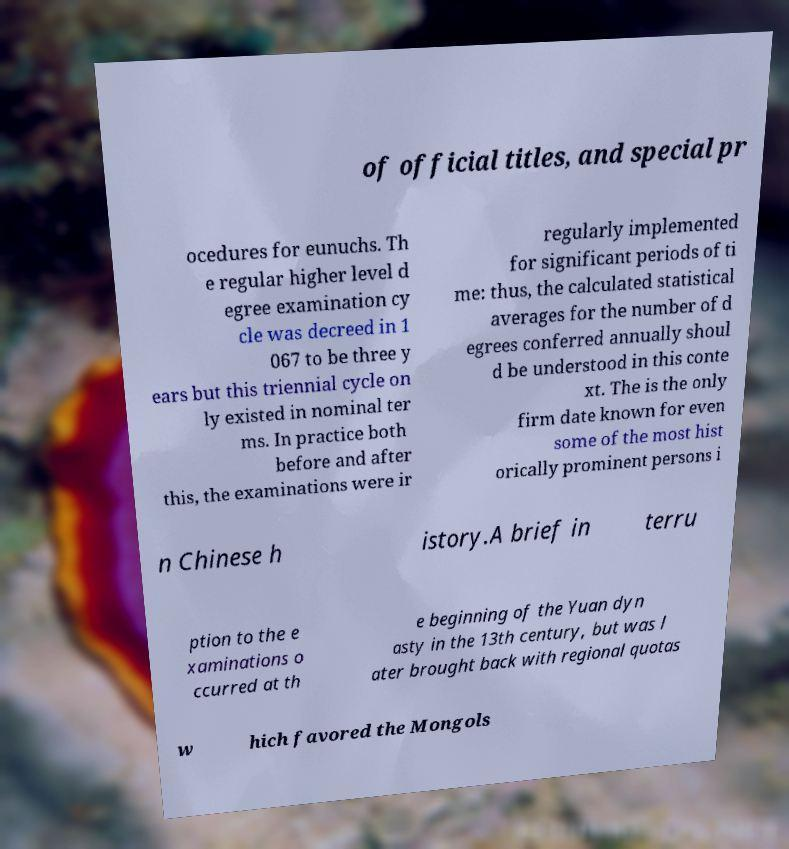Please read and relay the text visible in this image. What does it say? of official titles, and special pr ocedures for eunuchs. Th e regular higher level d egree examination cy cle was decreed in 1 067 to be three y ears but this triennial cycle on ly existed in nominal ter ms. In practice both before and after this, the examinations were ir regularly implemented for significant periods of ti me: thus, the calculated statistical averages for the number of d egrees conferred annually shoul d be understood in this conte xt. The is the only firm date known for even some of the most hist orically prominent persons i n Chinese h istory.A brief in terru ption to the e xaminations o ccurred at th e beginning of the Yuan dyn asty in the 13th century, but was l ater brought back with regional quotas w hich favored the Mongols 